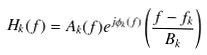Convert formula to latex. <formula><loc_0><loc_0><loc_500><loc_500>H _ { k } ( f ) = A _ { k } ( f ) e ^ { j \phi _ { k } ( f ) } \left ( \frac { f - f _ { k } } { B _ { k } } \right )</formula> 